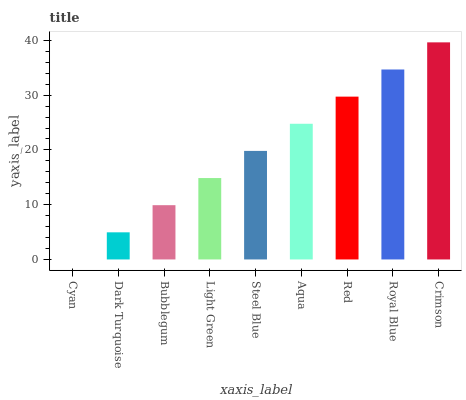Is Cyan the minimum?
Answer yes or no. Yes. Is Crimson the maximum?
Answer yes or no. Yes. Is Dark Turquoise the minimum?
Answer yes or no. No. Is Dark Turquoise the maximum?
Answer yes or no. No. Is Dark Turquoise greater than Cyan?
Answer yes or no. Yes. Is Cyan less than Dark Turquoise?
Answer yes or no. Yes. Is Cyan greater than Dark Turquoise?
Answer yes or no. No. Is Dark Turquoise less than Cyan?
Answer yes or no. No. Is Steel Blue the high median?
Answer yes or no. Yes. Is Steel Blue the low median?
Answer yes or no. Yes. Is Royal Blue the high median?
Answer yes or no. No. Is Red the low median?
Answer yes or no. No. 